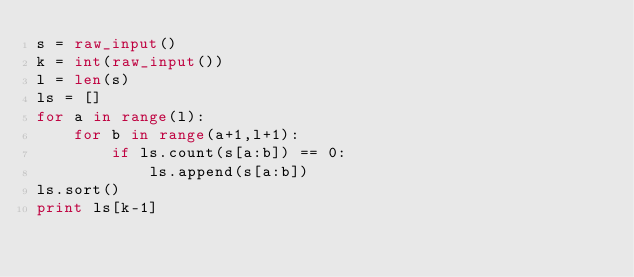<code> <loc_0><loc_0><loc_500><loc_500><_Python_>s = raw_input()
k = int(raw_input())
l = len(s)
ls = []
for a in range(l):
    for b in range(a+1,l+1):
        if ls.count(s[a:b]) == 0:
            ls.append(s[a:b])
ls.sort()
print ls[k-1]</code> 